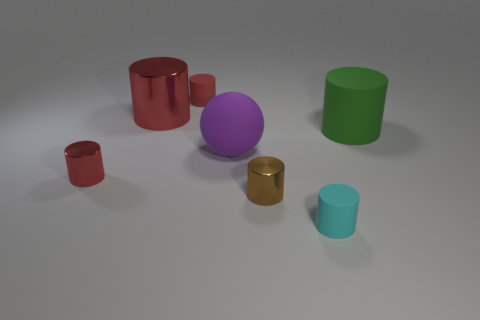Subtract all small metal cylinders. How many cylinders are left? 4 Subtract all cylinders. How many objects are left? 1 Add 3 red cylinders. How many objects exist? 10 Subtract all red cylinders. How many cylinders are left? 3 Subtract all red cylinders. Subtract all brown blocks. How many cylinders are left? 3 Subtract all yellow cubes. How many cyan cylinders are left? 1 Subtract all big yellow rubber cylinders. Subtract all small rubber cylinders. How many objects are left? 5 Add 3 tiny red matte objects. How many tiny red matte objects are left? 4 Add 4 big blocks. How many big blocks exist? 4 Subtract 0 green blocks. How many objects are left? 7 